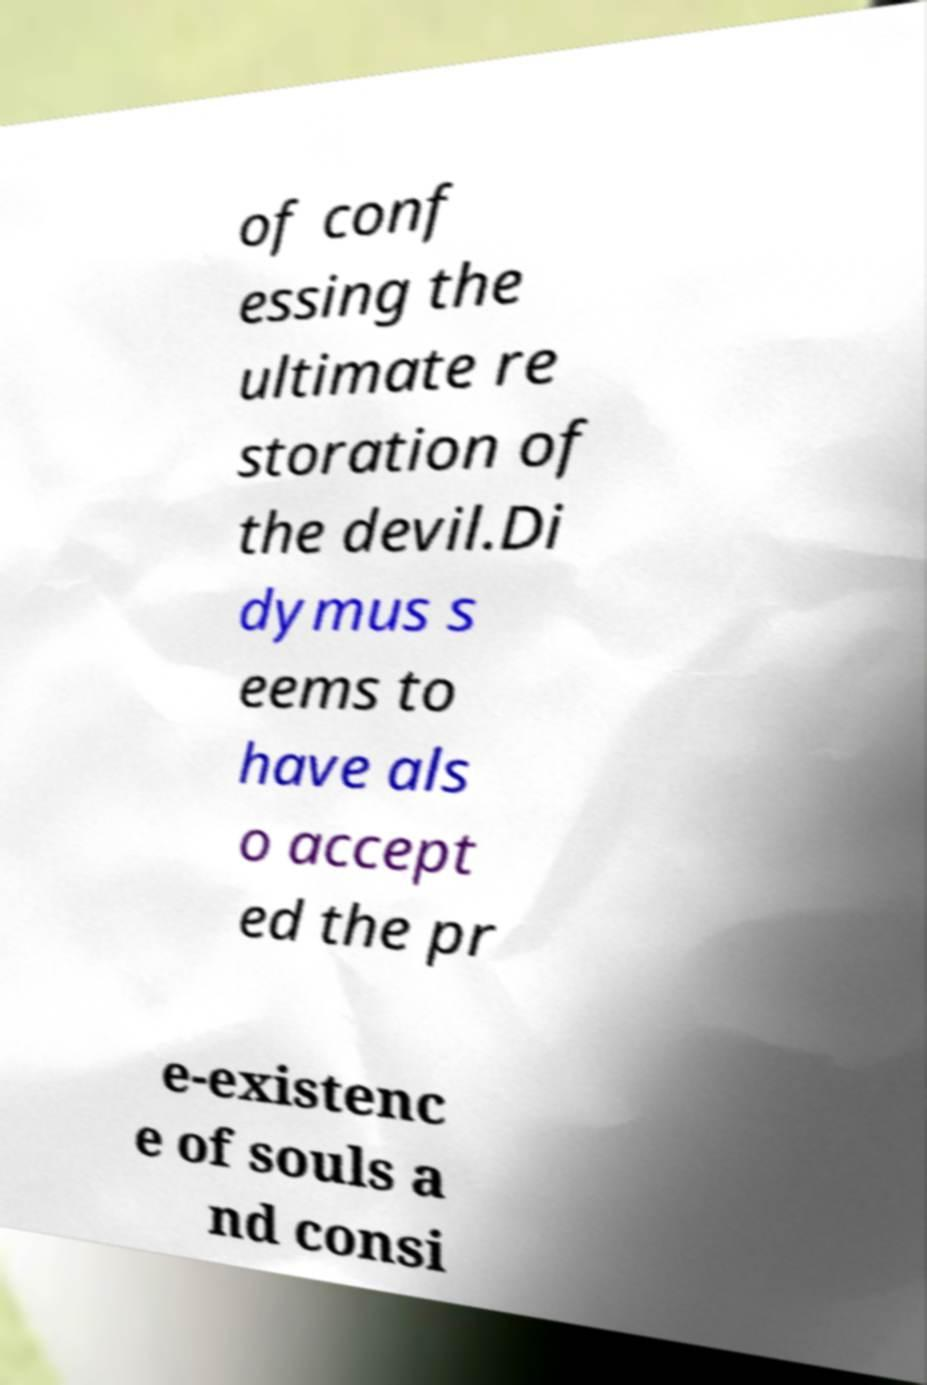Could you extract and type out the text from this image? of conf essing the ultimate re storation of the devil.Di dymus s eems to have als o accept ed the pr e-existenc e of souls a nd consi 